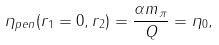<formula> <loc_0><loc_0><loc_500><loc_500>\eta _ { p e n } ( r _ { 1 } = 0 , r _ { 2 } ) = \frac { \alpha m _ { \pi } } { Q } = \eta _ { 0 } ,</formula> 